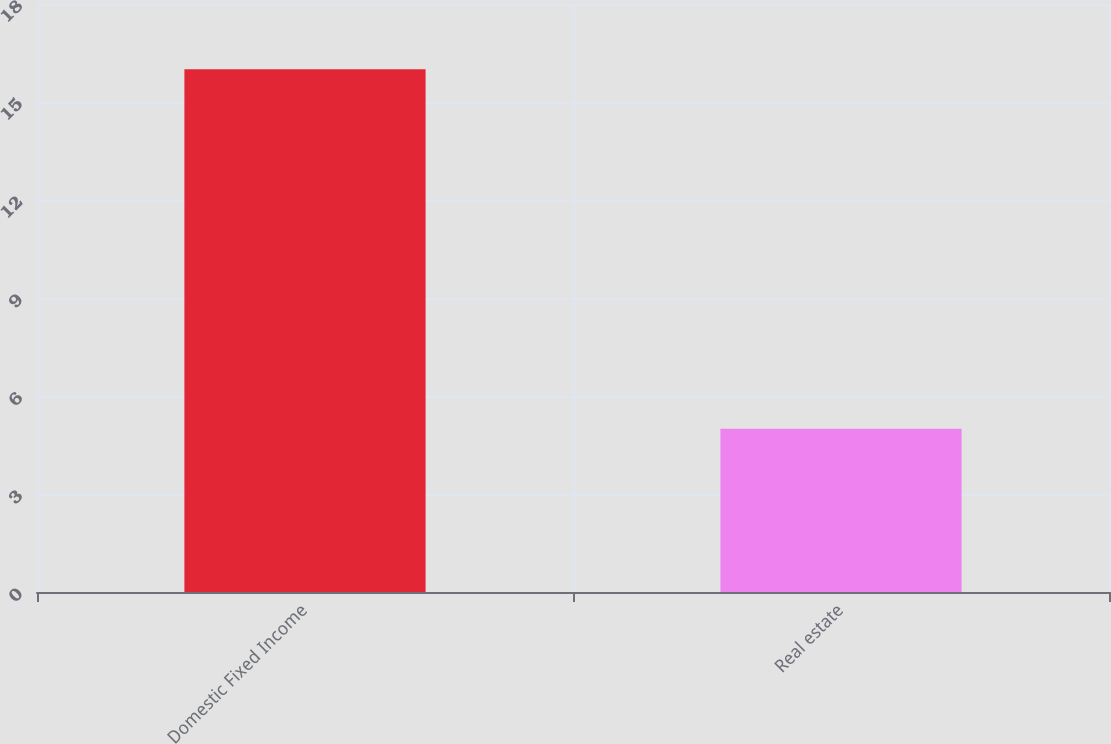Convert chart. <chart><loc_0><loc_0><loc_500><loc_500><bar_chart><fcel>Domestic Fixed Income<fcel>Real estate<nl><fcel>16<fcel>5<nl></chart> 